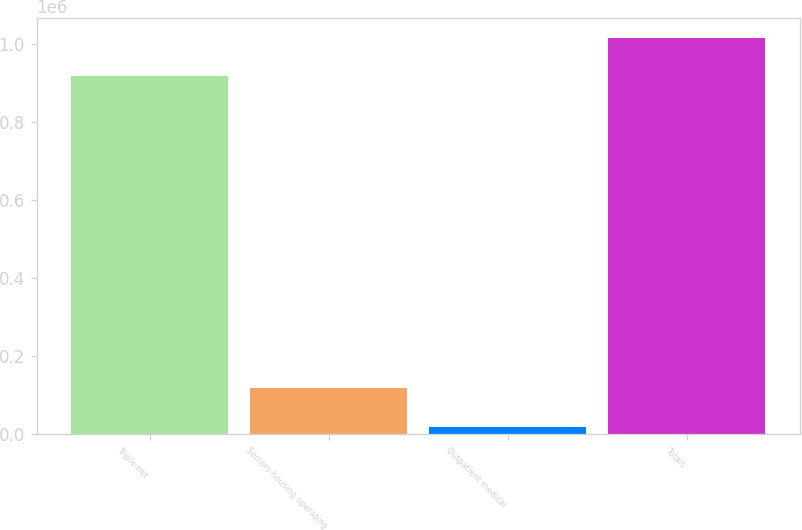Convert chart to OTSL. <chart><loc_0><loc_0><loc_500><loc_500><bar_chart><fcel>Triple-net<fcel>Seniors housing operating<fcel>Outpatient medical<fcel>Totals<nl><fcel>916689<fcel>118849<fcel>19697<fcel>1.01584e+06<nl></chart> 